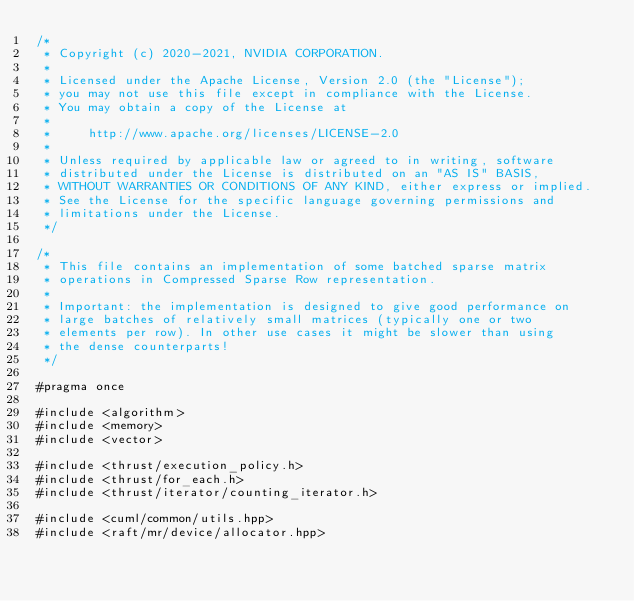<code> <loc_0><loc_0><loc_500><loc_500><_Cuda_>/*
 * Copyright (c) 2020-2021, NVIDIA CORPORATION.
 *
 * Licensed under the Apache License, Version 2.0 (the "License");
 * you may not use this file except in compliance with the License.
 * You may obtain a copy of the License at
 *
 *     http://www.apache.org/licenses/LICENSE-2.0
 *
 * Unless required by applicable law or agreed to in writing, software
 * distributed under the License is distributed on an "AS IS" BASIS,
 * WITHOUT WARRANTIES OR CONDITIONS OF ANY KIND, either express or implied.
 * See the License for the specific language governing permissions and
 * limitations under the License.
 */

/*
 * This file contains an implementation of some batched sparse matrix
 * operations in Compressed Sparse Row representation.
 * 
 * Important: the implementation is designed to give good performance on
 * large batches of relatively small matrices (typically one or two
 * elements per row). In other use cases it might be slower than using
 * the dense counterparts!
 */

#pragma once

#include <algorithm>
#include <memory>
#include <vector>

#include <thrust/execution_policy.h>
#include <thrust/for_each.h>
#include <thrust/iterator/counting_iterator.h>

#include <cuml/common/utils.hpp>
#include <raft/mr/device/allocator.hpp>
</code> 